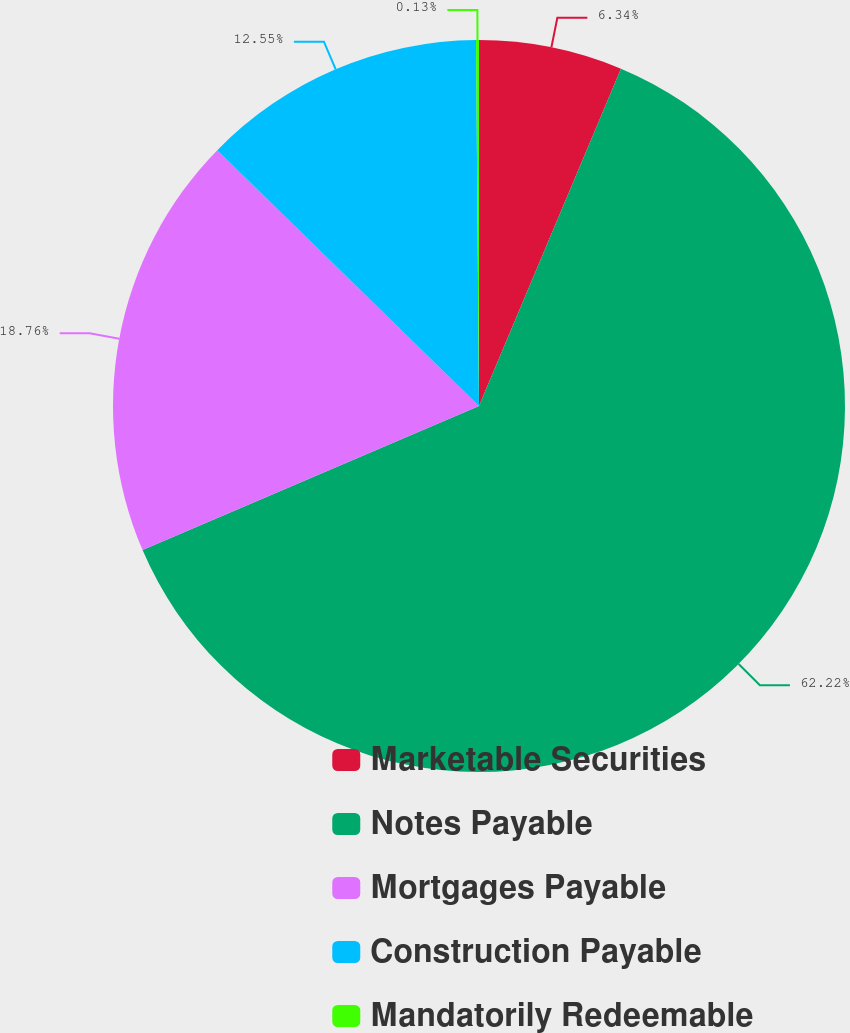<chart> <loc_0><loc_0><loc_500><loc_500><pie_chart><fcel>Marketable Securities<fcel>Notes Payable<fcel>Mortgages Payable<fcel>Construction Payable<fcel>Mandatorily Redeemable<nl><fcel>6.34%<fcel>62.22%<fcel>18.76%<fcel>12.55%<fcel>0.13%<nl></chart> 